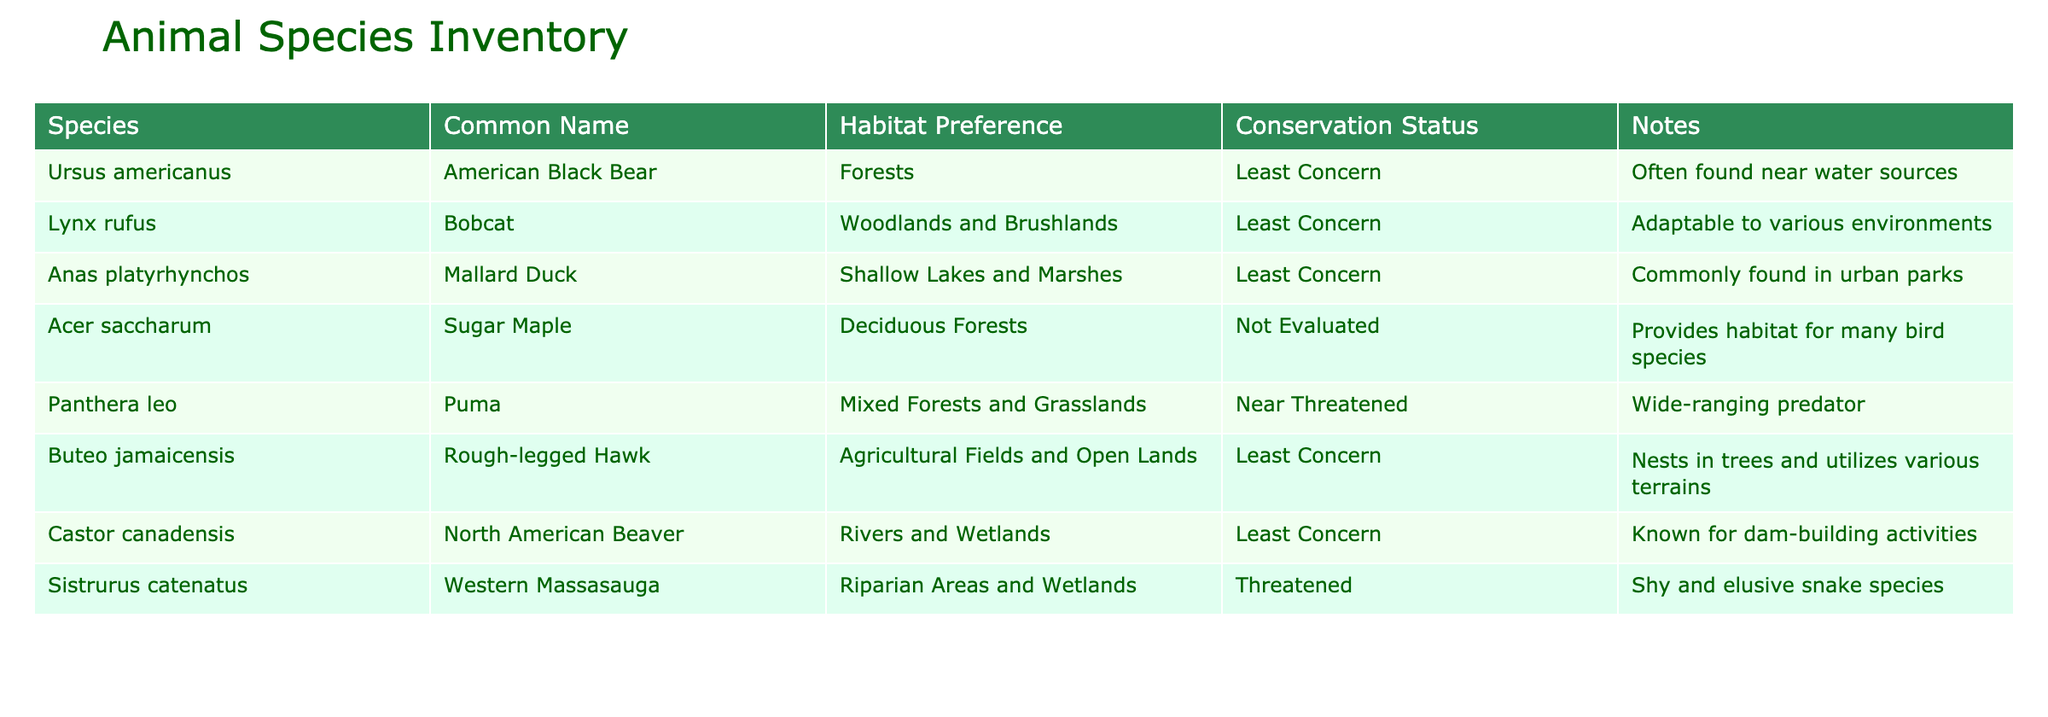What is the conservation status of the American Black Bear? The conservation status of the American Black Bear is listed as "Least Concern" in the table.
Answer: Least Concern Which species can be found in riparian areas and wetlands? The species found in riparian areas and wetlands, as mentioned in the table, is the Western Massasauga.
Answer: Western Massasauga How many species have a conservation status of Least Concern? There are six species categorized as Least Concern: American Black Bear, Bobcat, Mallard Duck, Rough-legged Hawk, North American Beaver. Therefore, the total is 5 species with that status.
Answer: 5 Do any species in the table prefer urban parks as their habitat? Yes, the Mallard Duck is specifically noted as commonly found in urban parks.
Answer: Yes Which species prefers mixed forests and grasslands, and what is its conservation status? The species that prefers mixed forests and grasslands is the Puma, and its conservation status is Near Threatened.
Answer: Puma, Near Threatened What habitat preference is shared by the Rough-legged Hawk and the North American Beaver? The Rough-legged Hawk prefers Agricultural Fields and Open Lands, while the North American Beaver prefers Rivers and Wetlands. They do not share a habitat preference.
Answer: No shared preference Among the species listed, which one is known for its dam-building activities? The North American Beaver is known for its dam-building activities as noted in the table.
Answer: North American Beaver What percentage of the species listed are categorized as Threatened? There is one species categorized as Threatened, and since there are seven species in total, the percentage is (1/7)*100 = approximately 14.29%.
Answer: Approximately 14.29% 